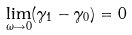<formula> <loc_0><loc_0><loc_500><loc_500>\lim _ { \omega \rightarrow 0 } ( \gamma _ { 1 } - \gamma _ { 0 } ) = 0</formula> 